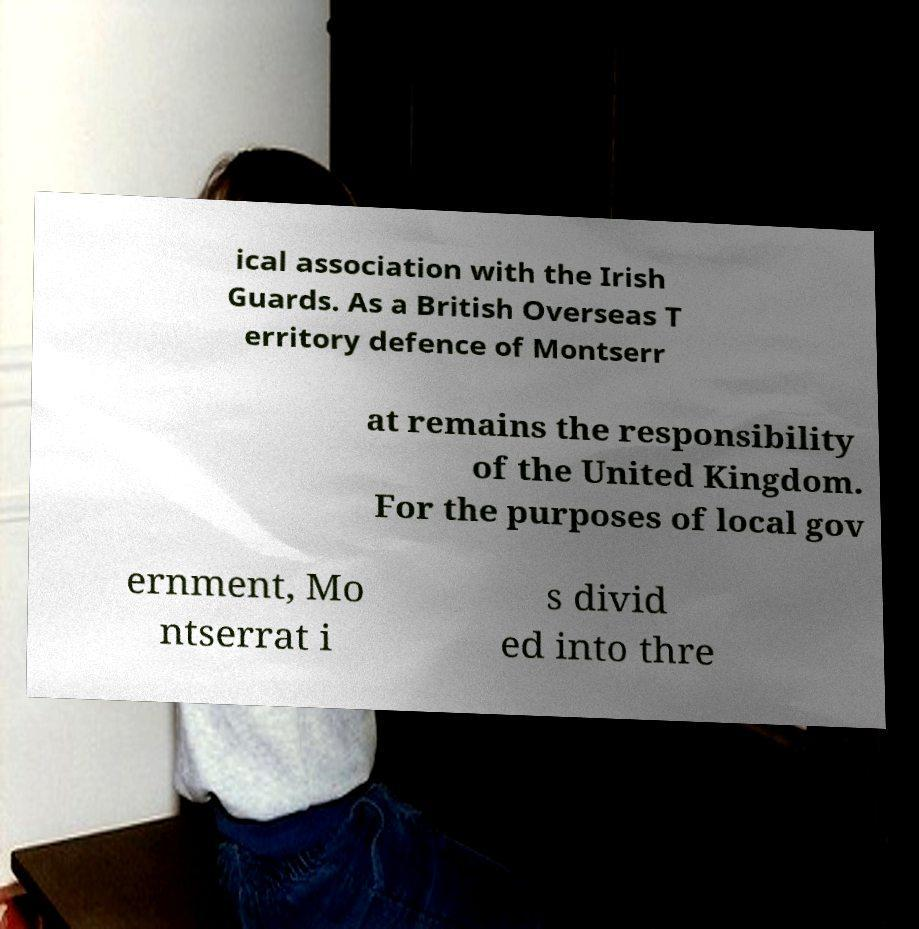I need the written content from this picture converted into text. Can you do that? ical association with the Irish Guards. As a British Overseas T erritory defence of Montserr at remains the responsibility of the United Kingdom. For the purposes of local gov ernment, Mo ntserrat i s divid ed into thre 